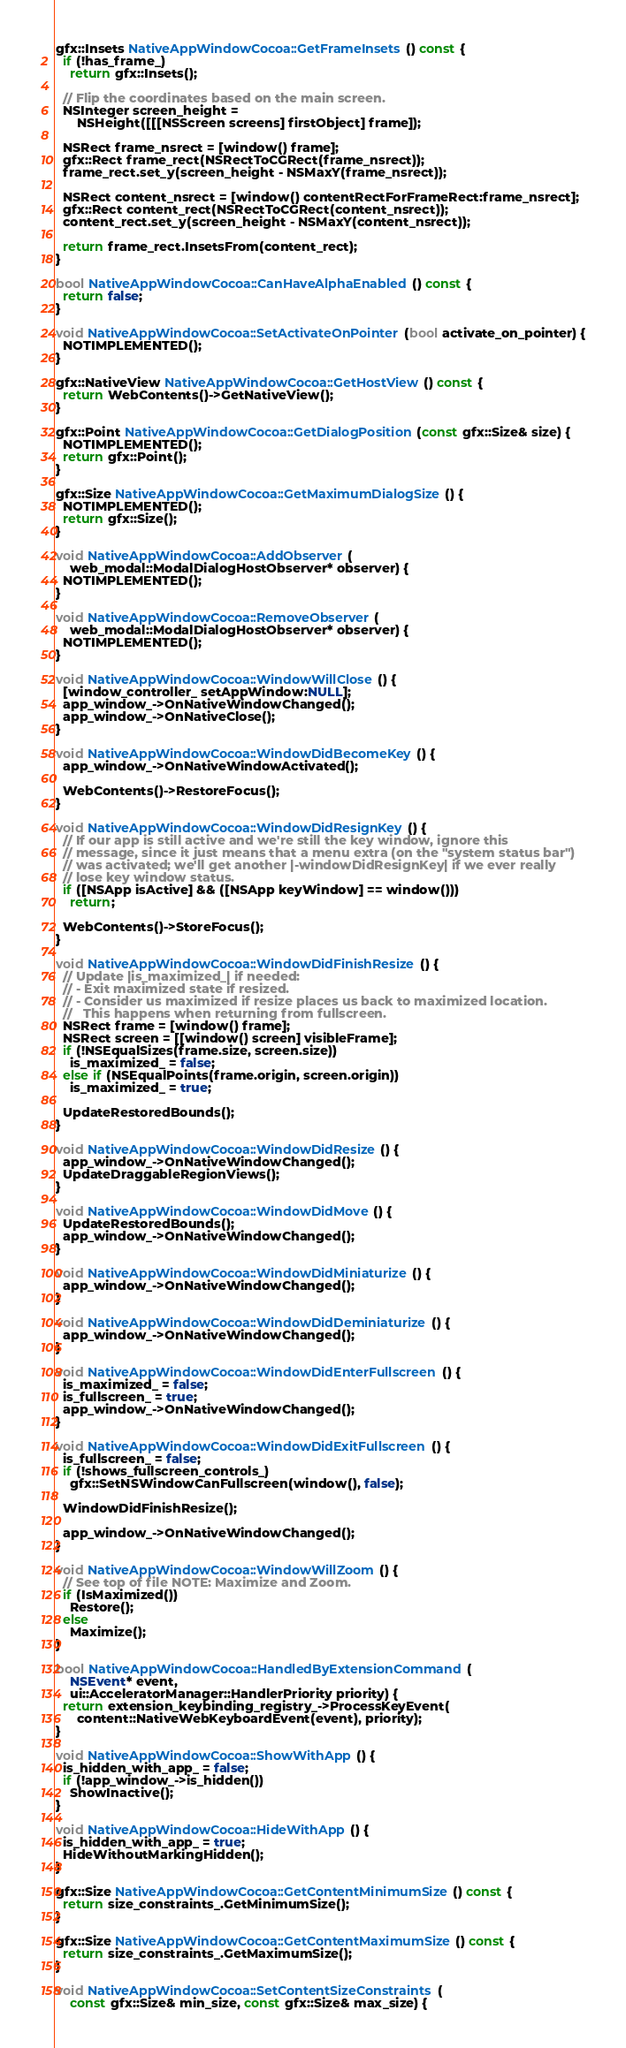<code> <loc_0><loc_0><loc_500><loc_500><_ObjectiveC_>
gfx::Insets NativeAppWindowCocoa::GetFrameInsets() const {
  if (!has_frame_)
    return gfx::Insets();

  // Flip the coordinates based on the main screen.
  NSInteger screen_height =
      NSHeight([[[NSScreen screens] firstObject] frame]);

  NSRect frame_nsrect = [window() frame];
  gfx::Rect frame_rect(NSRectToCGRect(frame_nsrect));
  frame_rect.set_y(screen_height - NSMaxY(frame_nsrect));

  NSRect content_nsrect = [window() contentRectForFrameRect:frame_nsrect];
  gfx::Rect content_rect(NSRectToCGRect(content_nsrect));
  content_rect.set_y(screen_height - NSMaxY(content_nsrect));

  return frame_rect.InsetsFrom(content_rect);
}

bool NativeAppWindowCocoa::CanHaveAlphaEnabled() const {
  return false;
}

void NativeAppWindowCocoa::SetActivateOnPointer(bool activate_on_pointer) {
  NOTIMPLEMENTED();
}

gfx::NativeView NativeAppWindowCocoa::GetHostView() const {
  return WebContents()->GetNativeView();
}

gfx::Point NativeAppWindowCocoa::GetDialogPosition(const gfx::Size& size) {
  NOTIMPLEMENTED();
  return gfx::Point();
}

gfx::Size NativeAppWindowCocoa::GetMaximumDialogSize() {
  NOTIMPLEMENTED();
  return gfx::Size();
}

void NativeAppWindowCocoa::AddObserver(
    web_modal::ModalDialogHostObserver* observer) {
  NOTIMPLEMENTED();
}

void NativeAppWindowCocoa::RemoveObserver(
    web_modal::ModalDialogHostObserver* observer) {
  NOTIMPLEMENTED();
}

void NativeAppWindowCocoa::WindowWillClose() {
  [window_controller_ setAppWindow:NULL];
  app_window_->OnNativeWindowChanged();
  app_window_->OnNativeClose();
}

void NativeAppWindowCocoa::WindowDidBecomeKey() {
  app_window_->OnNativeWindowActivated();

  WebContents()->RestoreFocus();
}

void NativeAppWindowCocoa::WindowDidResignKey() {
  // If our app is still active and we're still the key window, ignore this
  // message, since it just means that a menu extra (on the "system status bar")
  // was activated; we'll get another |-windowDidResignKey| if we ever really
  // lose key window status.
  if ([NSApp isActive] && ([NSApp keyWindow] == window()))
    return;

  WebContents()->StoreFocus();
}

void NativeAppWindowCocoa::WindowDidFinishResize() {
  // Update |is_maximized_| if needed:
  // - Exit maximized state if resized.
  // - Consider us maximized if resize places us back to maximized location.
  //   This happens when returning from fullscreen.
  NSRect frame = [window() frame];
  NSRect screen = [[window() screen] visibleFrame];
  if (!NSEqualSizes(frame.size, screen.size))
    is_maximized_ = false;
  else if (NSEqualPoints(frame.origin, screen.origin))
    is_maximized_ = true;

  UpdateRestoredBounds();
}

void NativeAppWindowCocoa::WindowDidResize() {
  app_window_->OnNativeWindowChanged();
  UpdateDraggableRegionViews();
}

void NativeAppWindowCocoa::WindowDidMove() {
  UpdateRestoredBounds();
  app_window_->OnNativeWindowChanged();
}

void NativeAppWindowCocoa::WindowDidMiniaturize() {
  app_window_->OnNativeWindowChanged();
}

void NativeAppWindowCocoa::WindowDidDeminiaturize() {
  app_window_->OnNativeWindowChanged();
}

void NativeAppWindowCocoa::WindowDidEnterFullscreen() {
  is_maximized_ = false;
  is_fullscreen_ = true;
  app_window_->OnNativeWindowChanged();
}

void NativeAppWindowCocoa::WindowDidExitFullscreen() {
  is_fullscreen_ = false;
  if (!shows_fullscreen_controls_)
    gfx::SetNSWindowCanFullscreen(window(), false);

  WindowDidFinishResize();

  app_window_->OnNativeWindowChanged();
}

void NativeAppWindowCocoa::WindowWillZoom() {
  // See top of file NOTE: Maximize and Zoom.
  if (IsMaximized())
    Restore();
  else
    Maximize();
}

bool NativeAppWindowCocoa::HandledByExtensionCommand(
    NSEvent* event,
    ui::AcceleratorManager::HandlerPriority priority) {
  return extension_keybinding_registry_->ProcessKeyEvent(
      content::NativeWebKeyboardEvent(event), priority);
}

void NativeAppWindowCocoa::ShowWithApp() {
  is_hidden_with_app_ = false;
  if (!app_window_->is_hidden())
    ShowInactive();
}

void NativeAppWindowCocoa::HideWithApp() {
  is_hidden_with_app_ = true;
  HideWithoutMarkingHidden();
}

gfx::Size NativeAppWindowCocoa::GetContentMinimumSize() const {
  return size_constraints_.GetMinimumSize();
}

gfx::Size NativeAppWindowCocoa::GetContentMaximumSize() const {
  return size_constraints_.GetMaximumSize();
}

void NativeAppWindowCocoa::SetContentSizeConstraints(
    const gfx::Size& min_size, const gfx::Size& max_size) {</code> 